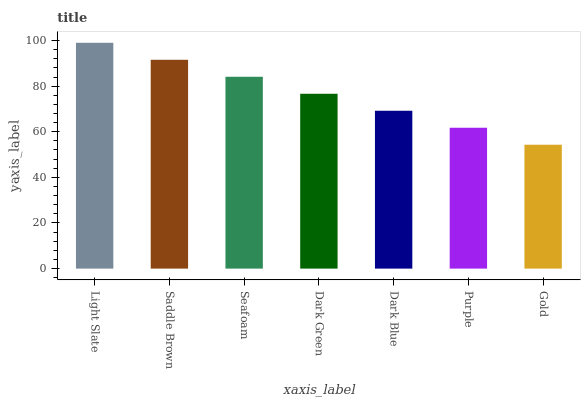Is Saddle Brown the minimum?
Answer yes or no. No. Is Saddle Brown the maximum?
Answer yes or no. No. Is Light Slate greater than Saddle Brown?
Answer yes or no. Yes. Is Saddle Brown less than Light Slate?
Answer yes or no. Yes. Is Saddle Brown greater than Light Slate?
Answer yes or no. No. Is Light Slate less than Saddle Brown?
Answer yes or no. No. Is Dark Green the high median?
Answer yes or no. Yes. Is Dark Green the low median?
Answer yes or no. Yes. Is Saddle Brown the high median?
Answer yes or no. No. Is Dark Blue the low median?
Answer yes or no. No. 